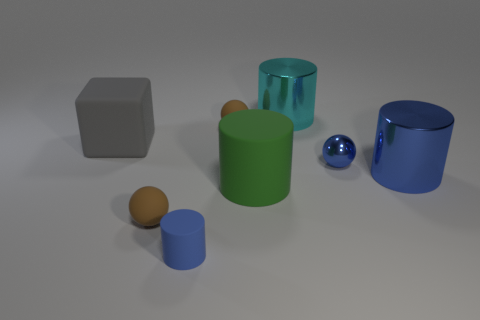There is a metal thing that is the same color as the shiny sphere; what shape is it?
Your answer should be compact. Cylinder. There is a tiny cylinder that is made of the same material as the big green object; what color is it?
Keep it short and to the point. Blue. There is a tiny cylinder on the left side of the blue cylinder that is right of the tiny blue cylinder; are there any small matte spheres in front of it?
Provide a succinct answer. No. There is a small metal thing; what shape is it?
Provide a short and direct response. Sphere. Is the number of brown objects on the right side of the blue ball less than the number of tiny gray metal cylinders?
Your response must be concise. No. Are there any other cyan things that have the same shape as the big cyan shiny object?
Your response must be concise. No. There is a cyan thing that is the same size as the cube; what shape is it?
Give a very brief answer. Cylinder. How many objects are either rubber cylinders or tiny rubber things?
Provide a short and direct response. 4. Is there a small green shiny thing?
Provide a short and direct response. No. Are there fewer gray matte objects than red cubes?
Offer a terse response. No. 